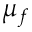<formula> <loc_0><loc_0><loc_500><loc_500>\mu _ { f }</formula> 